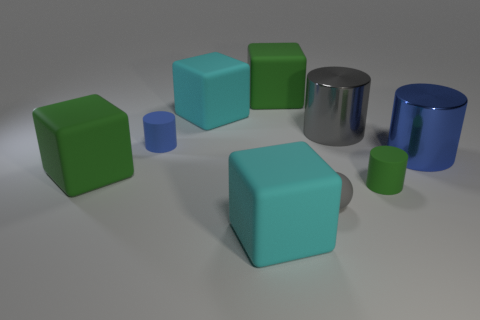What does the arrangement of colors and shapes tell us about the composition of this scene? In the image, there's a deliberate arrangement of colors and shapes that contribute to a balanced and harmonious composition. The diversity of shapes - cubes, cylinders, and spheres - are uniformly distributed, which draws the eye around the scene. Likewise, the colors are placed in such a way that cyan, blue, and green hues are interspersed throughout, creating a rhythm and preventing any one area of the composition from becoming visually stagnant. The result is aesthetically pleasing and encourages the viewer to consider the interplay between shape and color in three-dimensional space. 